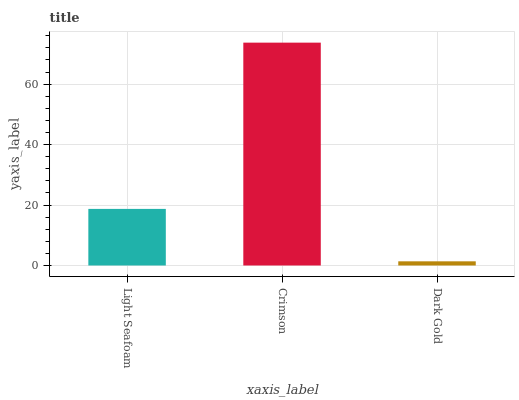Is Dark Gold the minimum?
Answer yes or no. Yes. Is Crimson the maximum?
Answer yes or no. Yes. Is Crimson the minimum?
Answer yes or no. No. Is Dark Gold the maximum?
Answer yes or no. No. Is Crimson greater than Dark Gold?
Answer yes or no. Yes. Is Dark Gold less than Crimson?
Answer yes or no. Yes. Is Dark Gold greater than Crimson?
Answer yes or no. No. Is Crimson less than Dark Gold?
Answer yes or no. No. Is Light Seafoam the high median?
Answer yes or no. Yes. Is Light Seafoam the low median?
Answer yes or no. Yes. Is Crimson the high median?
Answer yes or no. No. Is Crimson the low median?
Answer yes or no. No. 